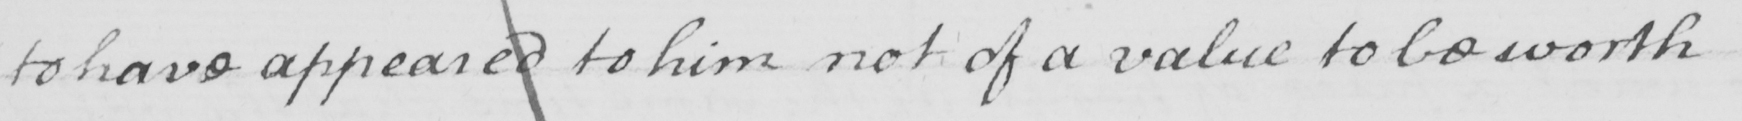Please transcribe the handwritten text in this image. to have appeared to him not of a value to be worth 